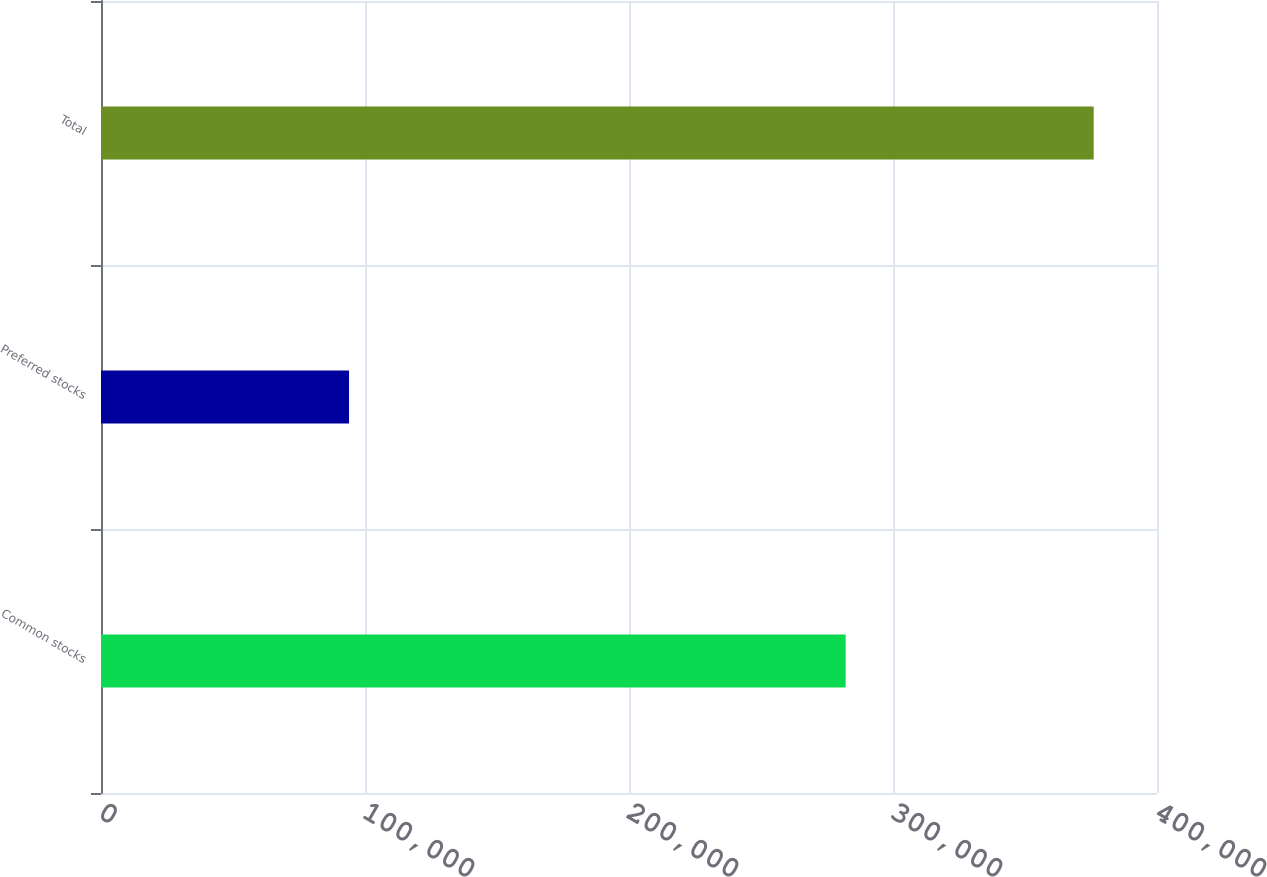Convert chart to OTSL. <chart><loc_0><loc_0><loc_500><loc_500><bar_chart><fcel>Common stocks<fcel>Preferred stocks<fcel>Total<nl><fcel>282066<fcel>93956<fcel>376022<nl></chart> 